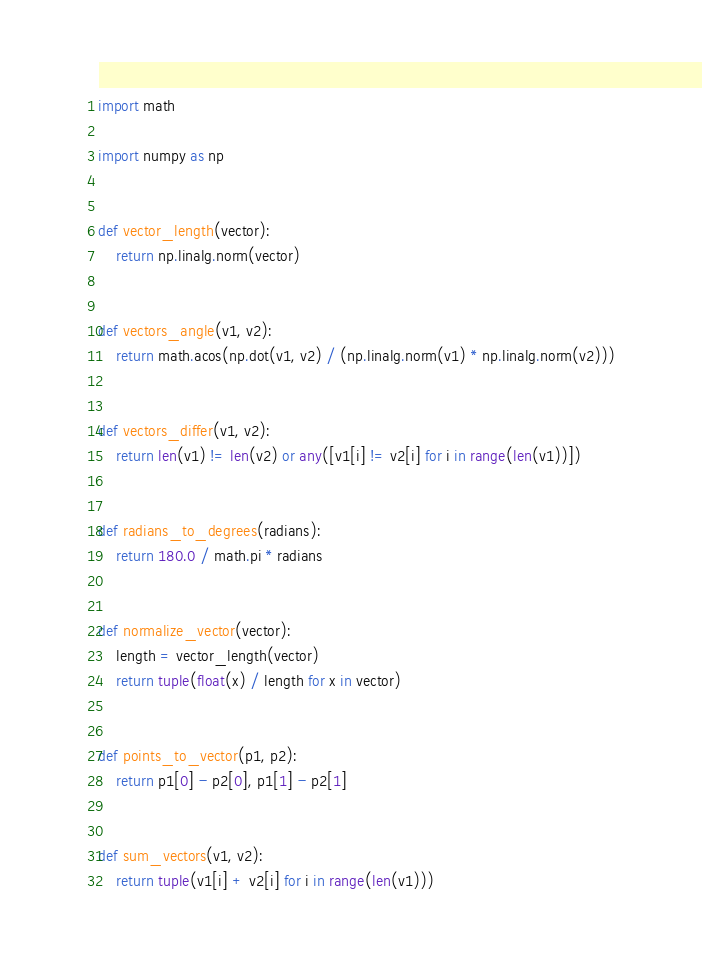Convert code to text. <code><loc_0><loc_0><loc_500><loc_500><_Python_>import math

import numpy as np


def vector_length(vector):
    return np.linalg.norm(vector)


def vectors_angle(v1, v2):
    return math.acos(np.dot(v1, v2) / (np.linalg.norm(v1) * np.linalg.norm(v2)))


def vectors_differ(v1, v2):
    return len(v1) != len(v2) or any([v1[i] != v2[i] for i in range(len(v1))])


def radians_to_degrees(radians):
    return 180.0 / math.pi * radians


def normalize_vector(vector):
    length = vector_length(vector)
    return tuple(float(x) / length for x in vector)


def points_to_vector(p1, p2):
    return p1[0] - p2[0], p1[1] - p2[1]


def sum_vectors(v1, v2):
    return tuple(v1[i] + v2[i] for i in range(len(v1)))</code> 